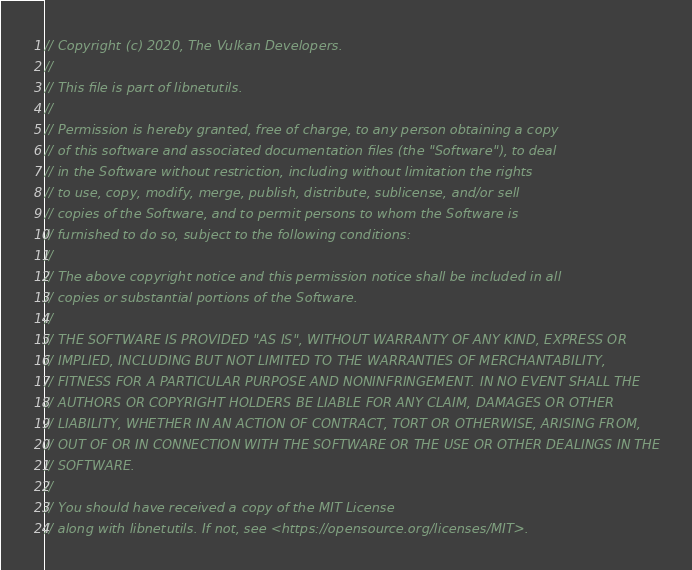Convert code to text. <code><loc_0><loc_0><loc_500><loc_500><_C++_>// Copyright (c) 2020, The Vulkan Developers.
//
// This file is part of libnetutils.
//
// Permission is hereby granted, free of charge, to any person obtaining a copy
// of this software and associated documentation files (the "Software"), to deal
// in the Software without restriction, including without limitation the rights
// to use, copy, modify, merge, publish, distribute, sublicense, and/or sell
// copies of the Software, and to permit persons to whom the Software is
// furnished to do so, subject to the following conditions:
//
// The above copyright notice and this permission notice shall be included in all
// copies or substantial portions of the Software.
//
// THE SOFTWARE IS PROVIDED "AS IS", WITHOUT WARRANTY OF ANY KIND, EXPRESS OR
// IMPLIED, INCLUDING BUT NOT LIMITED TO THE WARRANTIES OF MERCHANTABILITY,
// FITNESS FOR A PARTICULAR PURPOSE AND NONINFRINGEMENT. IN NO EVENT SHALL THE
// AUTHORS OR COPYRIGHT HOLDERS BE LIABLE FOR ANY CLAIM, DAMAGES OR OTHER
// LIABILITY, WHETHER IN AN ACTION OF CONTRACT, TORT OR OTHERWISE, ARISING FROM,
// OUT OF OR IN CONNECTION WITH THE SOFTWARE OR THE USE OR OTHER DEALINGS IN THE
// SOFTWARE.
//
// You should have received a copy of the MIT License
// along with libnetutils. If not, see <https://opensource.org/licenses/MIT>.
</code> 